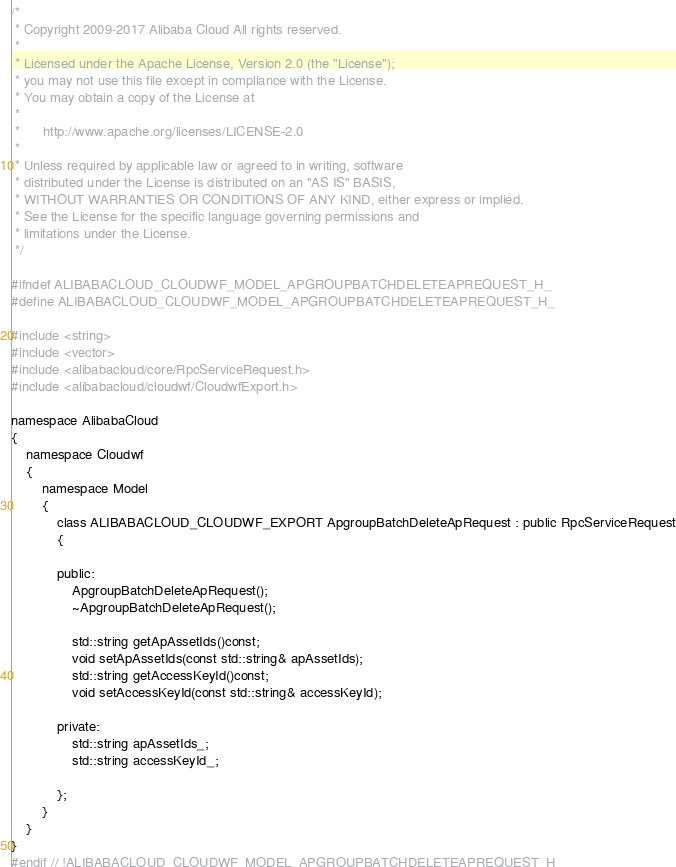<code> <loc_0><loc_0><loc_500><loc_500><_C_>/*
 * Copyright 2009-2017 Alibaba Cloud All rights reserved.
 * 
 * Licensed under the Apache License, Version 2.0 (the "License");
 * you may not use this file except in compliance with the License.
 * You may obtain a copy of the License at
 * 
 *      http://www.apache.org/licenses/LICENSE-2.0
 * 
 * Unless required by applicable law or agreed to in writing, software
 * distributed under the License is distributed on an "AS IS" BASIS,
 * WITHOUT WARRANTIES OR CONDITIONS OF ANY KIND, either express or implied.
 * See the License for the specific language governing permissions and
 * limitations under the License.
 */

#ifndef ALIBABACLOUD_CLOUDWF_MODEL_APGROUPBATCHDELETEAPREQUEST_H_
#define ALIBABACLOUD_CLOUDWF_MODEL_APGROUPBATCHDELETEAPREQUEST_H_

#include <string>
#include <vector>
#include <alibabacloud/core/RpcServiceRequest.h>
#include <alibabacloud/cloudwf/CloudwfExport.h>

namespace AlibabaCloud
{
	namespace Cloudwf
	{
		namespace Model
		{
			class ALIBABACLOUD_CLOUDWF_EXPORT ApgroupBatchDeleteApRequest : public RpcServiceRequest
			{

			public:
				ApgroupBatchDeleteApRequest();
				~ApgroupBatchDeleteApRequest();

				std::string getApAssetIds()const;
				void setApAssetIds(const std::string& apAssetIds);
				std::string getAccessKeyId()const;
				void setAccessKeyId(const std::string& accessKeyId);

            private:
				std::string apAssetIds_;
				std::string accessKeyId_;

			};
		}
	}
}
#endif // !ALIBABACLOUD_CLOUDWF_MODEL_APGROUPBATCHDELETEAPREQUEST_H_</code> 